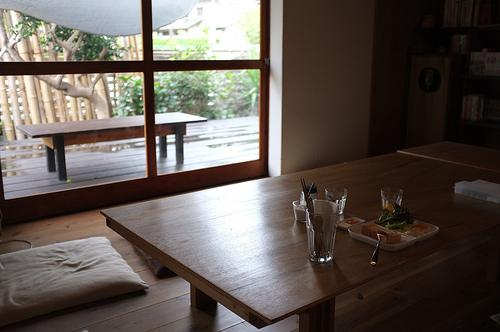What type of table is in the foreground, and what is on it? A wooden table with short legs is in the foreground, and it has a glass with utensils, a white tray with food, a silver fork, and a glass cup on it. Are there any distinctive objects in the image that might contribute to the feel of the scene, and what do they convey? The bonsai tree and wooden Japanese table create a calming atmosphere, and the books on the shelf in the background indicate an intellectual and homely setting. Explain the positional relationship between the table with food on it and the floor pillow. The table with food on it is in the foreground of the image, and the floor pillow is placed nearby on the left side, suggesting that the person may sit comfortably on the pillow and eat their meal on the table. What is the overall sentiment evoked by the image? The image evokes a feeling of warmth, comfort, and relaxation, inviting the viewer to imagine themselves sitting on the floor pillow and enjoying a meal in this serene indoor-outdoor setting. Provide a brief description of the prominent objects in the image. The image shows a low wooden table with food, utensils, and a glass, a pillow on the floor, a bench outside on the porch, and bookshelves in the background. Identify the objects seen through the window. Through the window, one can see a bench on the porch, a tree in the background, a bonsai tree, the backyard, a wooden table, and a bush with green leaves. In a single sentence, describe the overall setting and mood of the image. The image captures a cozy indoor scene with a low wooden table set for a meal, a floor pillow for sitting, and a serene outdoor view through a window with a lush backyard and wooden bench. Count the number of objects related to dining or eating in the image. There are seven objects related to dining or eating: a glass with utensils, a tray with food, a fork, a white tray with compartments, a silver fork on the table, a glass cup, and a plate of food. Describe the overall lighting and weather conditions of the image. The image has a bright and well-lit ambiance due to sunlight shining through the window, reflecting off the wooden table, and it is taken during the daytime. What is the primary purpose of the items displayed on the wooden table? The primary purpose of the items on the wooden table is for eating and serving food, as there are a tray with food, a glass with utensils, a fork, and a glass cup on it. Can you describe the interaction between the fork and the tray in the image? The fork is leaning on the tray. Please provide the details of the window in the image. A window with a wooden frame is in the background. Where are the books situated in the image? Books are on a shelf. Is there a pillow lying on the ground? Yes, there is a pillow on the floor. Recognize the activity happening in this scene. A meal is being prepared and served on the short-legged wooden table. How is the sunlight interacting with the table in the image? Light is reflecting off the table. Please describe the scene in the image including the major elements. A wooden table with a glass of utensils, a tray of food, and a fork, all located on a wood floor with a pillow, a bench on a porch, a bonsai tree, and bookshelves in the background. Is there any evidence to suggest that the image was taken during the day or night? Yes, the image was taken in the daytime as light is reflecting off the table. Describe the image as if it were a cozy indoor dining space. A cozy indoor dining space features a wooden table adorned with a white tray filled with delicious food, a glass with utensils, and a silver fork. A floor pillow invites guests to sit comfortably on the warm hardwood floor, while a nearby window offers a glimpse of a peaceful outdoor setting with a bench and a bonsai tree. What is the main object in the foreground of the image? A wooden table What are the contents of the glass located on the table? Utensils Identify the object in the image that is described as "off white pillow on a wood floor". A floor pillow for sitting Choose the best description for the image from the following options: Option A: A wooden table with a glass of utensils, a tray of food, a fork, a pillow on the floor, and a bench on a porch; Option B: A student's bedroom with a desk, computer, and textbooks; Option C: A living room with a sofa, coffee table, and television. Option A What type of food is on the tray? Green vegetables and some other food items. What is the color of the tray with food in it? White From which direction is the light reflecting off the table? There is no specific direction given in the information provided. What material is the floor made of? Brown hardwood Imagine the image as a Japanese style dining area and create a detailed description. A serene Japanese style dining area with a low wooden table holding a glass with chopsticks, a compartmentalized white plate with food, and a silver fork. A floor pillow lies on the light brown hardwood floor beside the table. In the background, a bonsai tree, bookshelves, and a wooden bench outside a window with a wood frame add to the peaceful ambiance. Which caption best communicates the contents of the glass on the table: Option A: Glass filled with orange juice; Option B: Glass with chopsticks inside; Option C: Glass with ice cubes? Option B Which object is described as "wooden bench on a porch"? A bench on the porch 